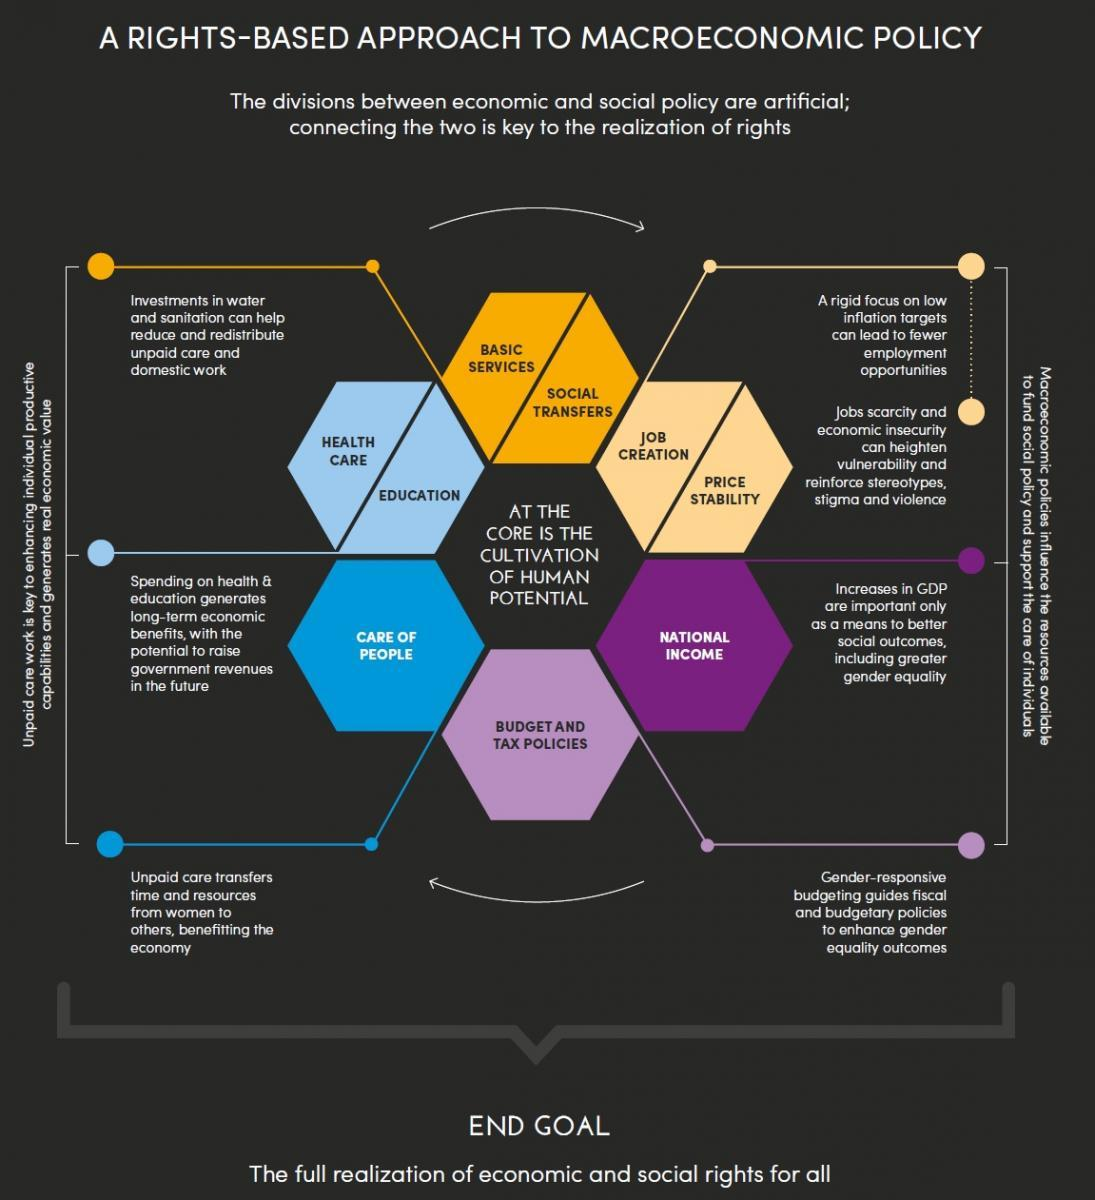List a handful of essential elements in this visual. The impact of unpaid care work on the economy has been a topic of much debate. Recent research suggests that the contribution of unpaid care work in improving the economy is multifaceted and includes a variety of dimensions. The macroeconomic policies aim to address and manage various aspects of the economy, with a primary focus on four key areas. Investing in education and health care, two aspects of unpaid care, generates long-term income for the government. In the process of dividing hexagons into two equal parts, 3 hexagons have been successfully divided. 